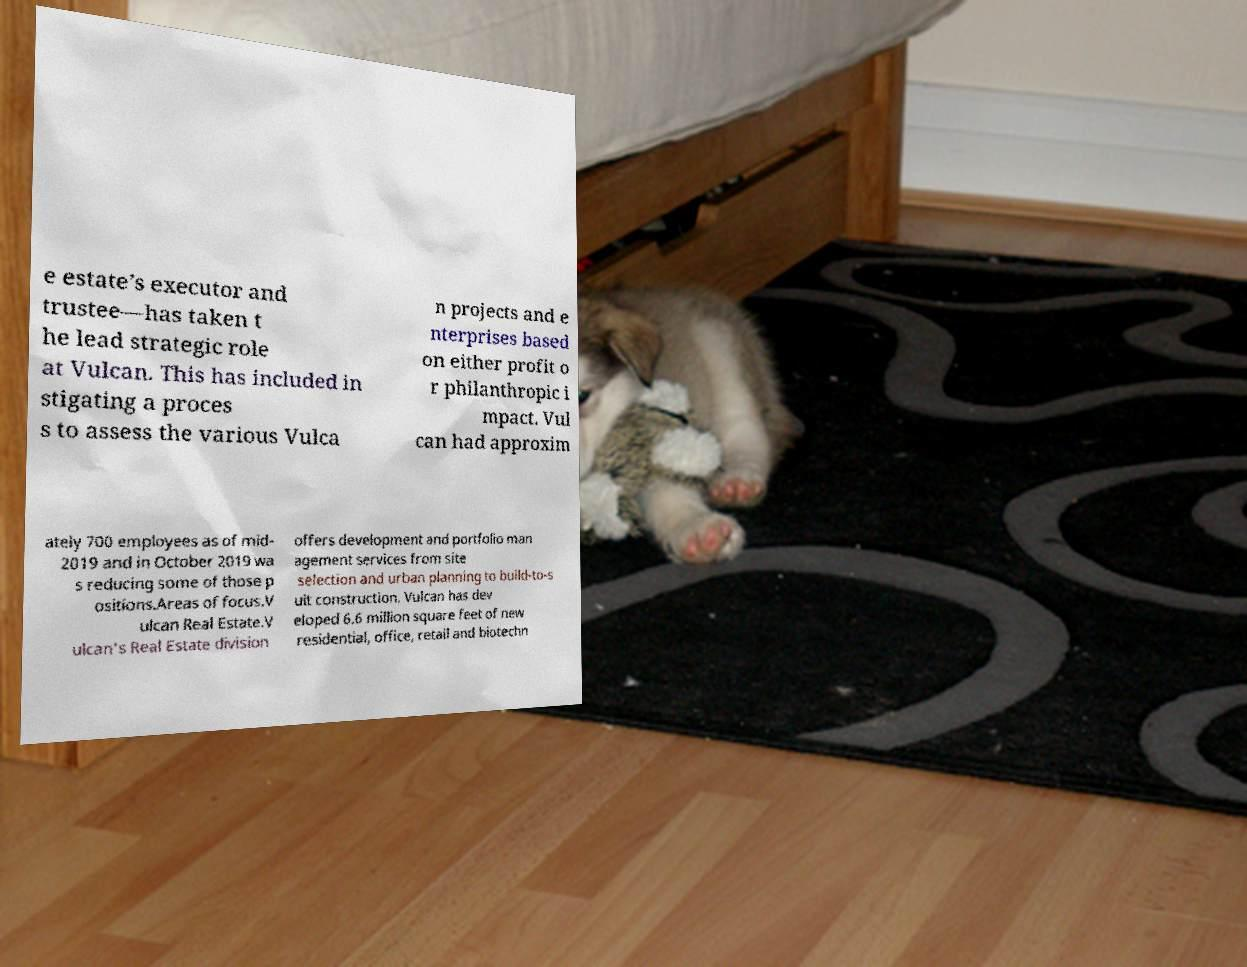Can you read and provide the text displayed in the image?This photo seems to have some interesting text. Can you extract and type it out for me? e estate’s executor and trustee—has taken t he lead strategic role at Vulcan. This has included in stigating a proces s to assess the various Vulca n projects and e nterprises based on either profit o r philanthropic i mpact. Vul can had approxim ately 700 employees as of mid- 2019 and in October 2019 wa s reducing some of those p ositions.Areas of focus.V ulcan Real Estate.V ulcan's Real Estate division offers development and portfolio man agement services from site selection and urban planning to build-to-s uit construction. Vulcan has dev eloped 6.6 million square feet of new residential, office, retail and biotechn 